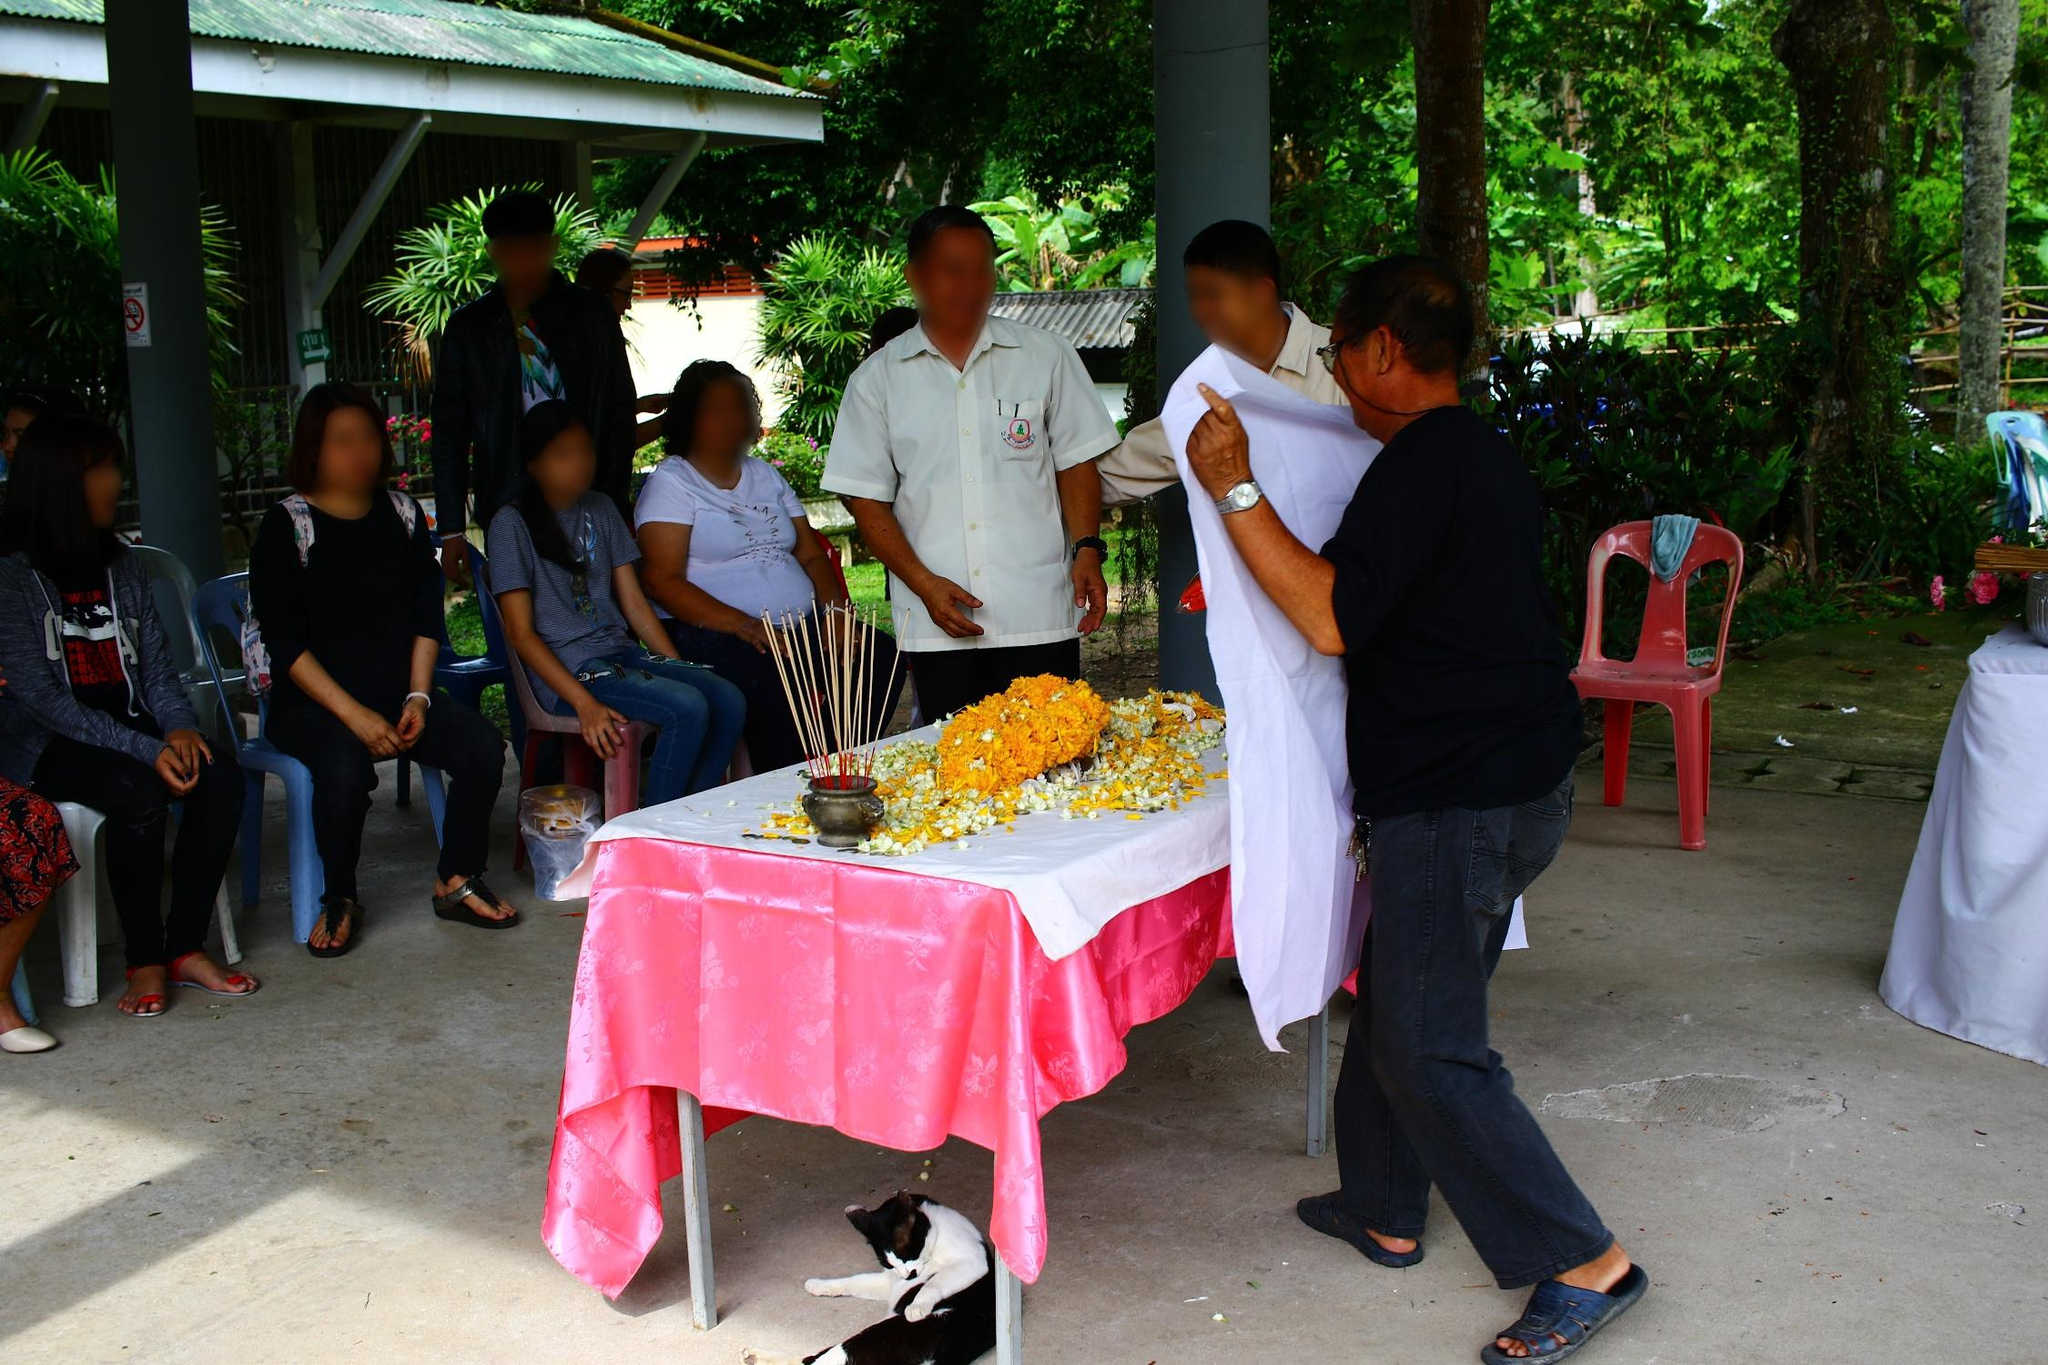What does the presence of the cat in this solemn setting suggest about the cultural attitudes towards animals? The presence of the cat, comfortably situated near the ceremony, indicates a cultural inclusiveness and a relaxed attitude towards animals. In many cultures, animals are considered part of the community and are often present during significant events, symbolizing good luck or protection. The casual acceptance of the cat's presence suggests it is not out of place in this scene, highlighting an integration of nature and communal life. How does the structure and setting influence the atmosphere of the event? The open structure and lush surrounding greenery contribute to a tranquil and refreshing atmosphere, suitable for gatherings and communal rites. The natural setting not only enhances the serene mood but also connects the participants to their environment, making the event feel more harmonious and grounded. This setting likely aids in fostering a sense of community and belonging among the attendees. 